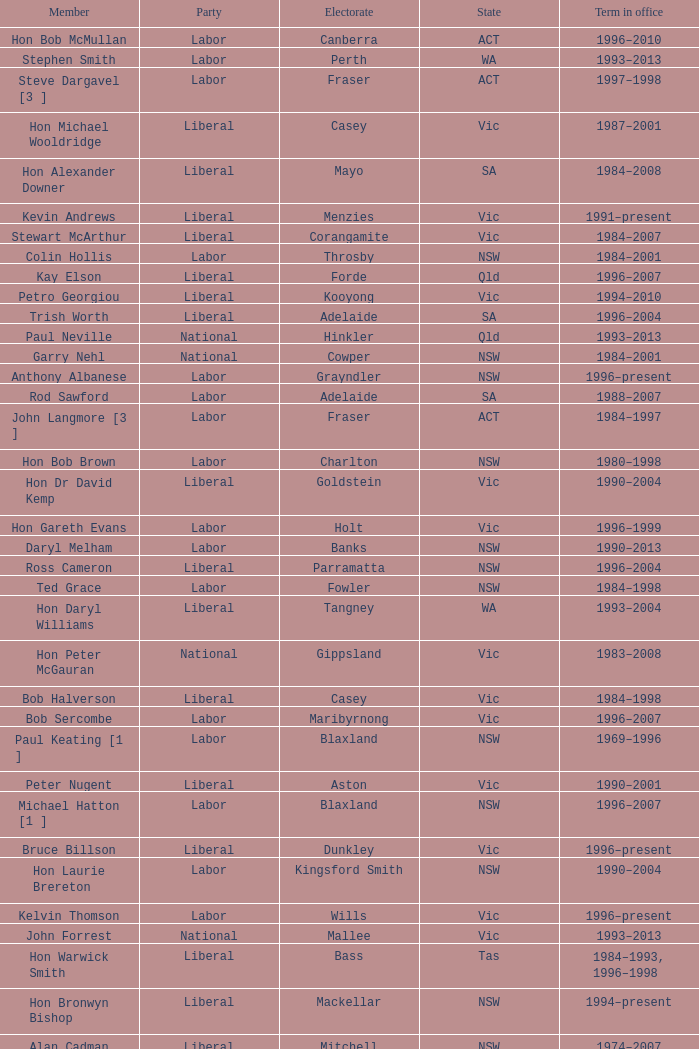In what state was the electorate fowler? NSW. 